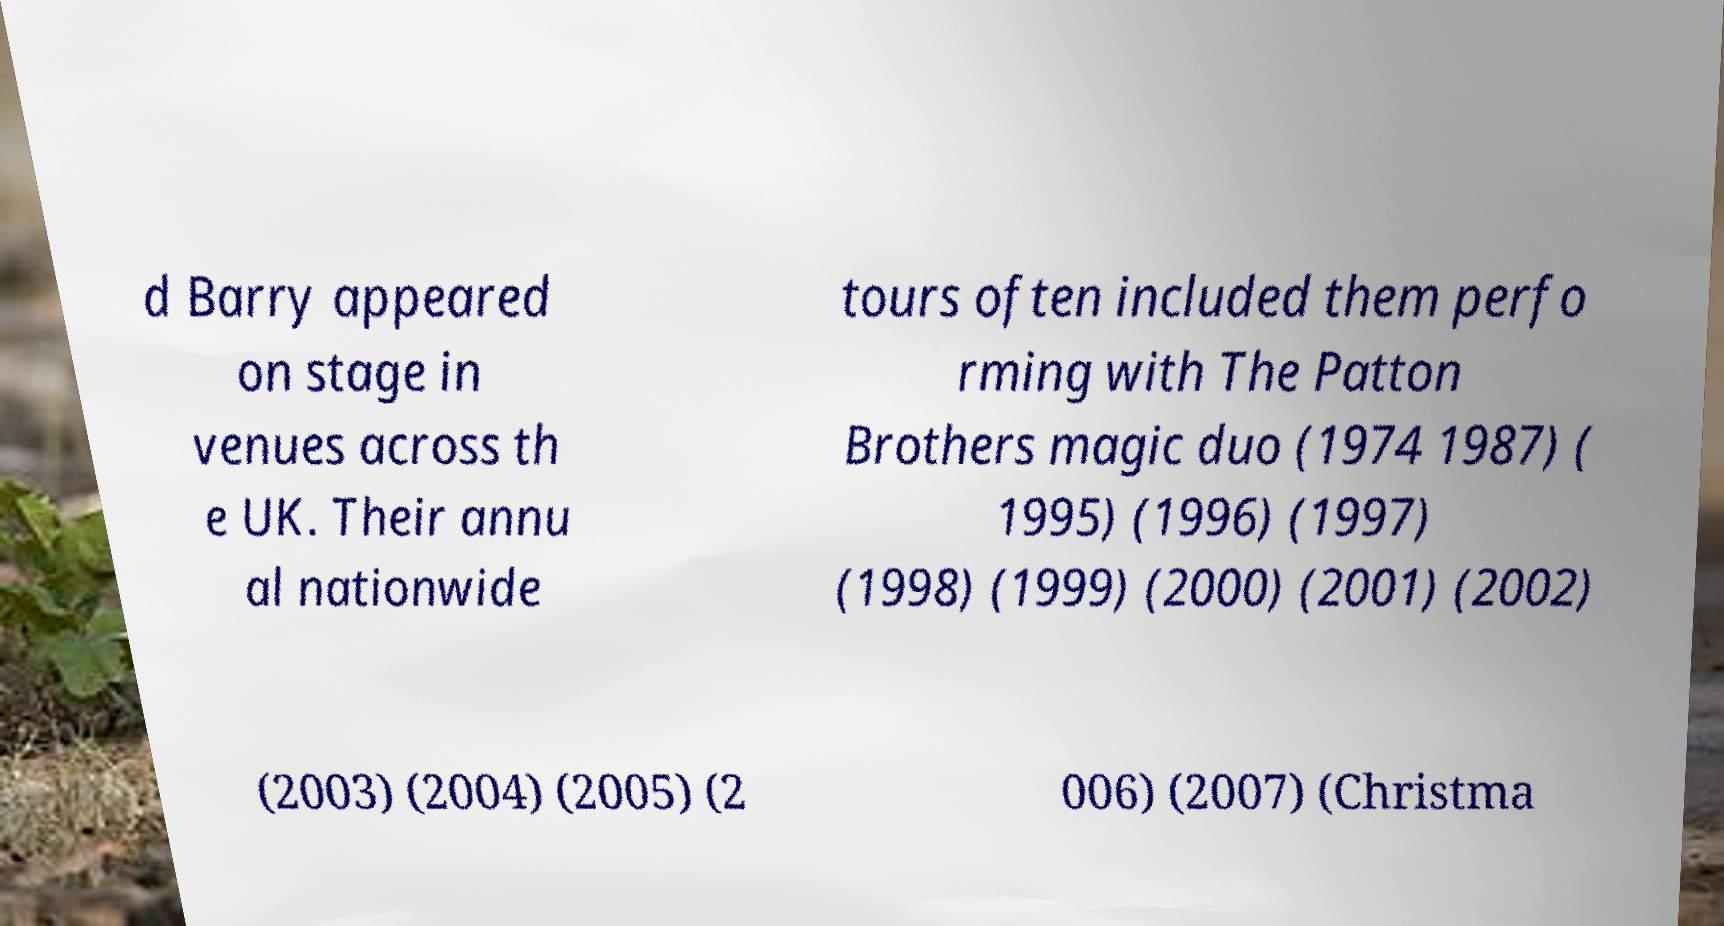What messages or text are displayed in this image? I need them in a readable, typed format. d Barry appeared on stage in venues across th e UK. Their annu al nationwide tours often included them perfo rming with The Patton Brothers magic duo (1974 1987) ( 1995) (1996) (1997) (1998) (1999) (2000) (2001) (2002) (2003) (2004) (2005) (2 006) (2007) (Christma 